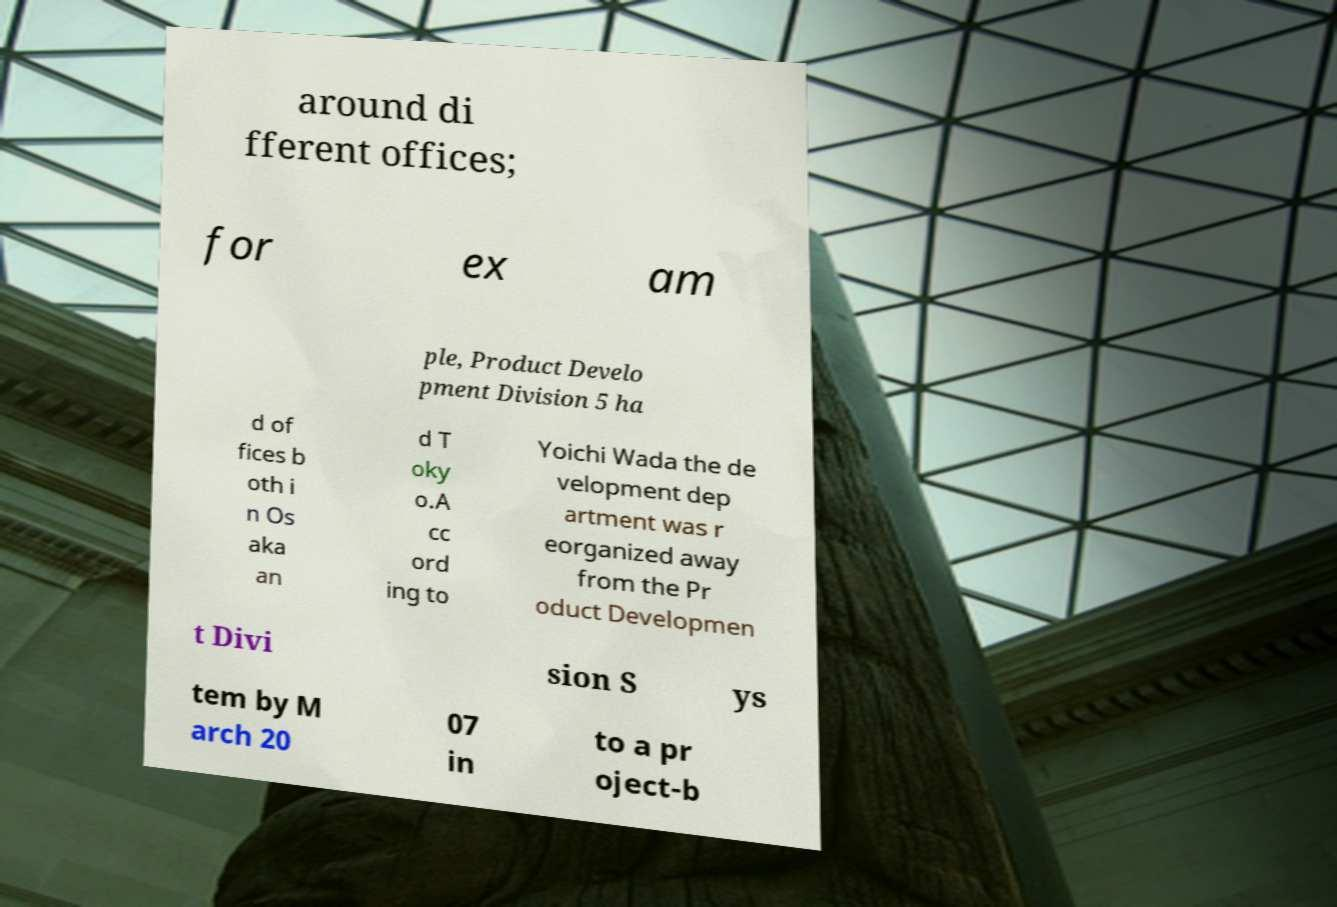What messages or text are displayed in this image? I need them in a readable, typed format. around di fferent offices; for ex am ple, Product Develo pment Division 5 ha d of fices b oth i n Os aka an d T oky o.A cc ord ing to Yoichi Wada the de velopment dep artment was r eorganized away from the Pr oduct Developmen t Divi sion S ys tem by M arch 20 07 in to a pr oject-b 